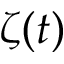Convert formula to latex. <formula><loc_0><loc_0><loc_500><loc_500>\zeta ( t )</formula> 